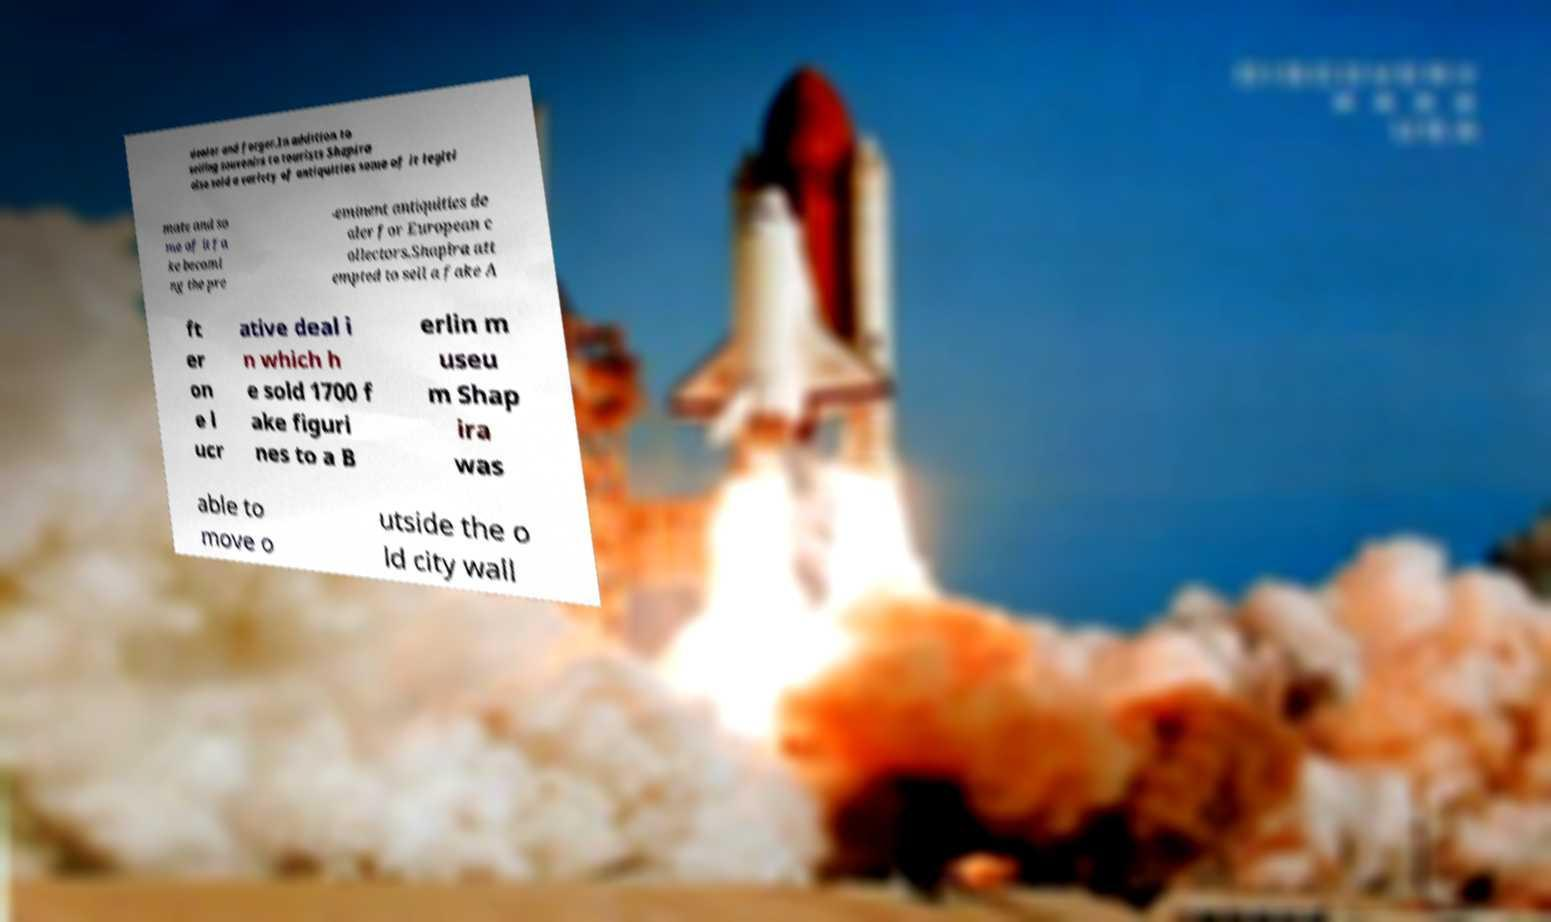Can you read and provide the text displayed in the image?This photo seems to have some interesting text. Can you extract and type it out for me? dealer and forger.In addition to selling souvenirs to tourists Shapira also sold a variety of antiquities some of it legiti mate and so me of it fa ke becomi ng the pre -eminent antiquities de aler for European c ollectors.Shapira att empted to sell a fake A ft er on e l ucr ative deal i n which h e sold 1700 f ake figuri nes to a B erlin m useu m Shap ira was able to move o utside the o ld city wall 